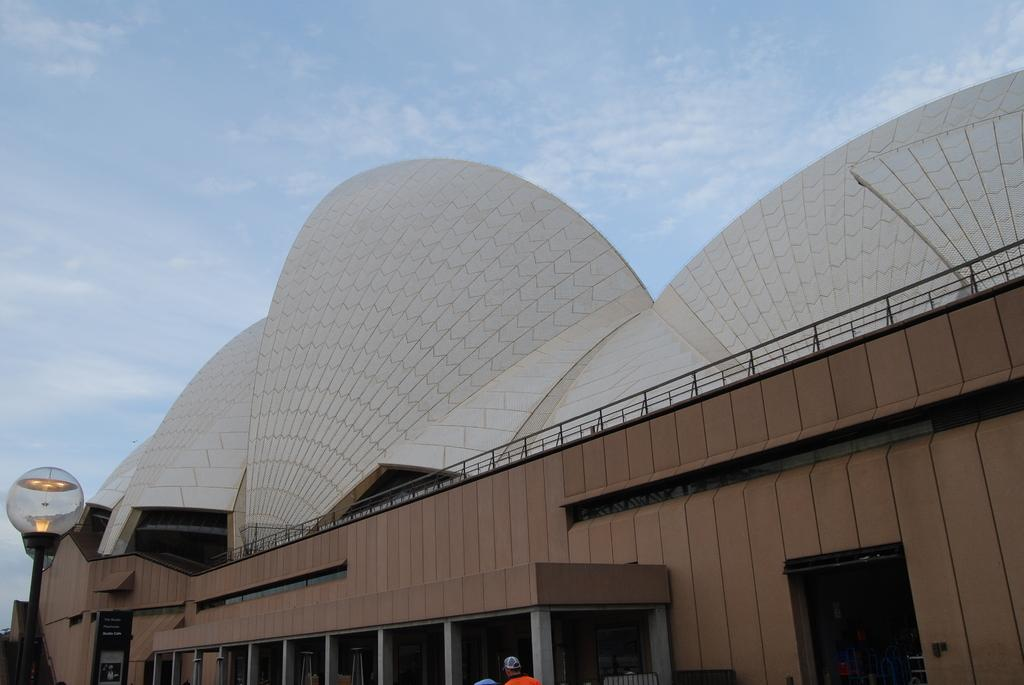What type of structure is present in the image? There is a building in the image. Can you describe the color of the building? The building is white and brown in color. Is there anyone present in the image? Yes, there is a person in the image. What can be seen in the background of the image? The sky is visible in the background of the image. What are the colors of the sky in the image? The sky is white and blue in color. What type of card is being used by the person in the image? There is no card present in the image; it only features a building, a person, and the sky. 